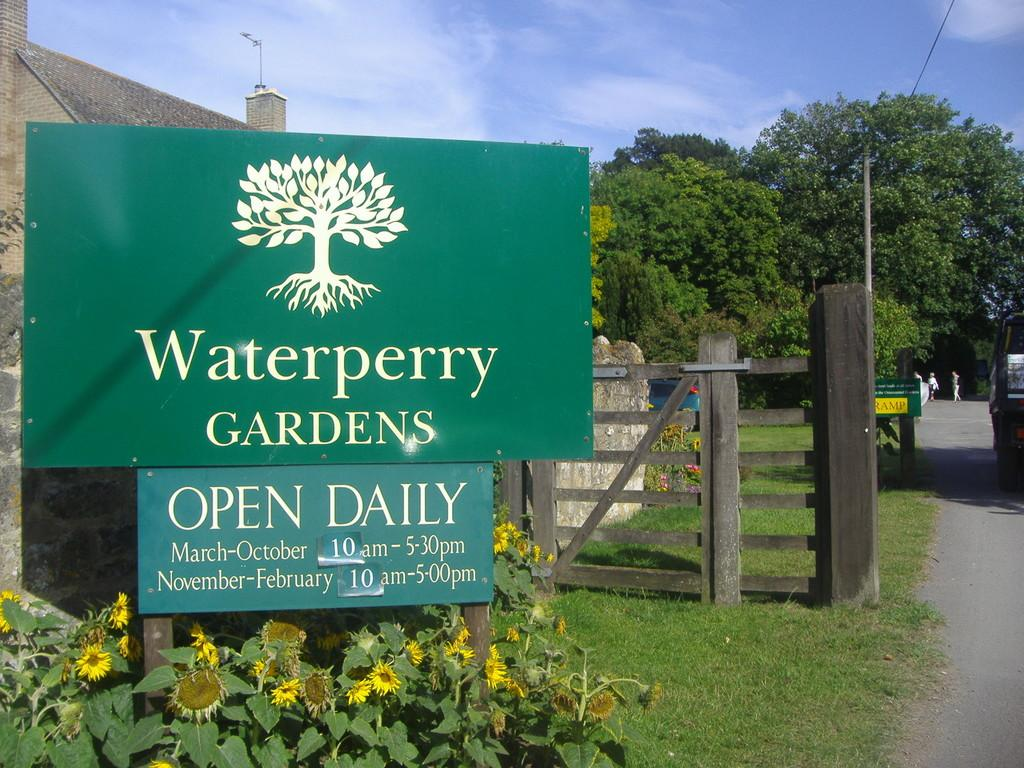What type of plants can be seen in the image? There are flower plants in the image. What is the purpose of the fence in the image? The fence serves as a boundary or barrier in the image. What can be seen on the green color boards in the image? There is writing on the green color boards in the image. What type of building is present in the image? There is a house in the image. What other types of vegetation are visible in the image? There are trees in the image. Can you describe any other objects present in the image? There are other objects in the image, but their specific details are not mentioned in the provided facts. What is visible in the background of the image? The sky is visible in the background of the image. Where is the girl playing in the image? There is no girl present in the image. How does the fold in the fence affect the appearance of the image? There is no mention of a fold in the fence in the provided facts, so it cannot be determined how it affects the appearance of the image. 